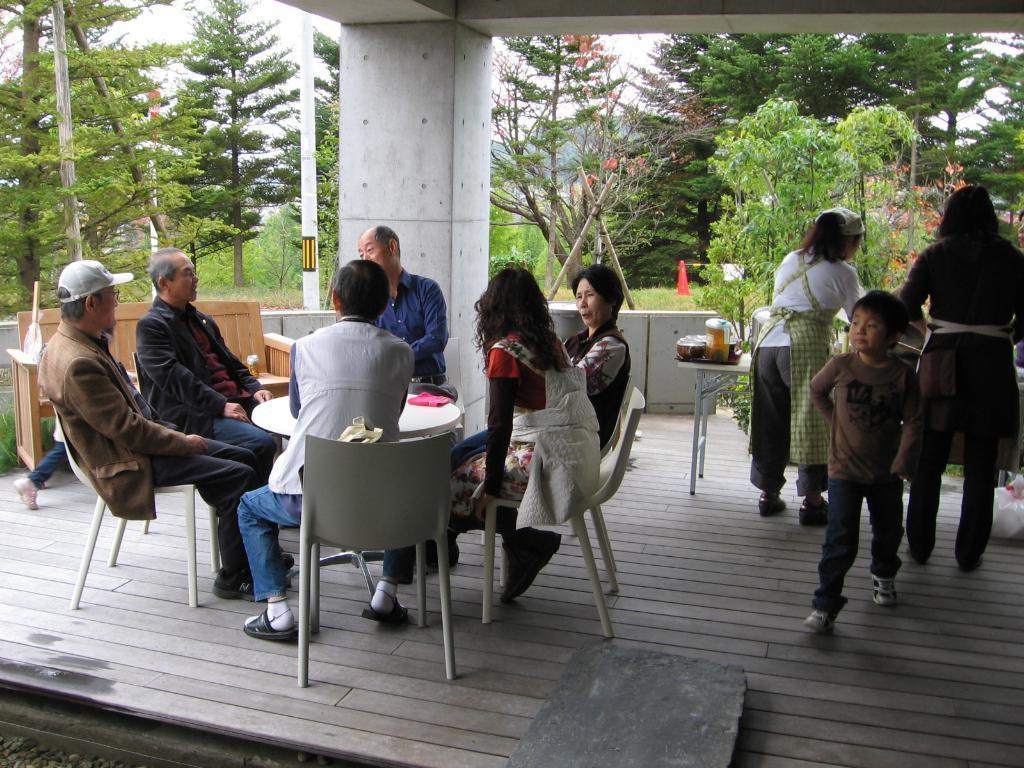Please provide a concise description of this image. The picture is taken outside where people are sitting on the chairs and between them there is a round table and behind them there is one bench and trees around them and at the right corner of the picture three people are standing and in front of them there is a table dishes, bowls are present. 